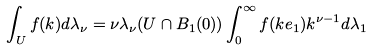<formula> <loc_0><loc_0><loc_500><loc_500>\int _ { U } f ( k ) d \lambda _ { \nu } = \nu \lambda _ { \nu } ( U \cap B _ { 1 } ( 0 ) ) \int _ { 0 } ^ { \infty } f ( k e _ { 1 } ) k ^ { \nu - 1 } d \lambda _ { 1 }</formula> 